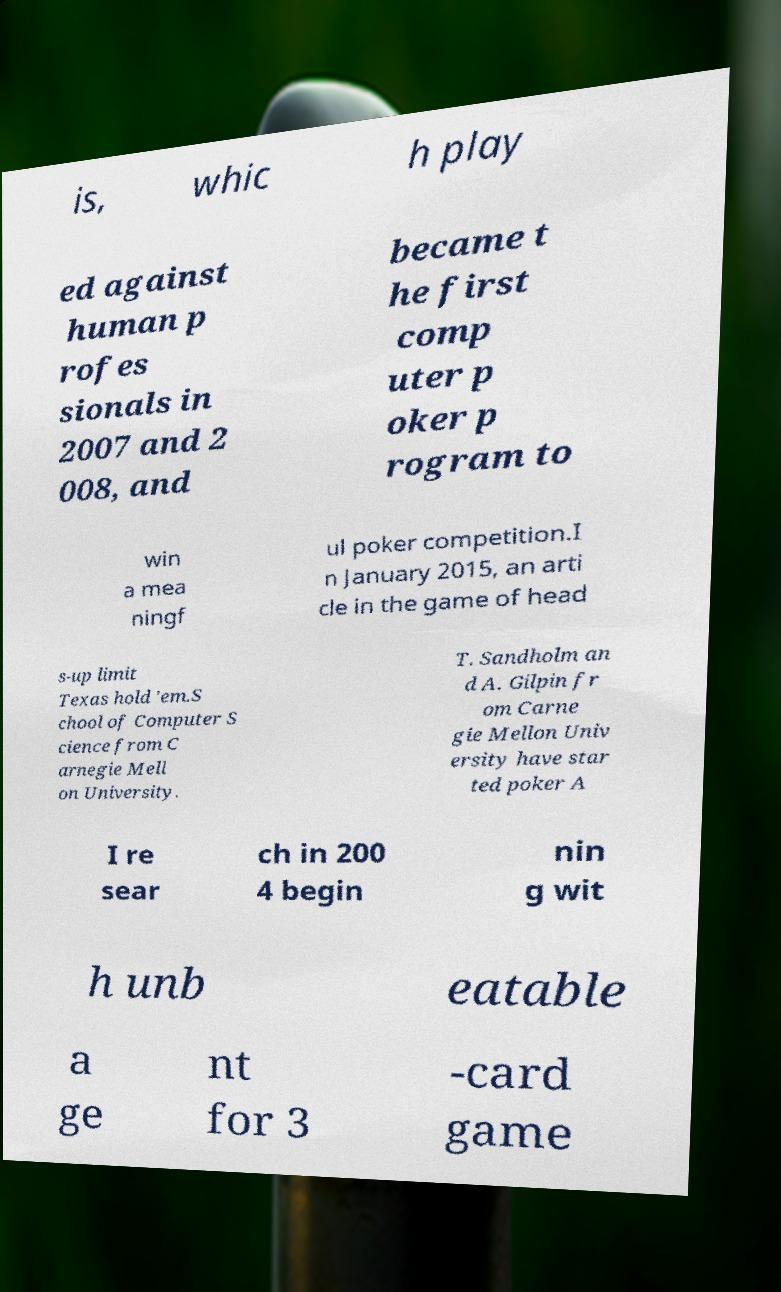What messages or text are displayed in this image? I need them in a readable, typed format. is, whic h play ed against human p rofes sionals in 2007 and 2 008, and became t he first comp uter p oker p rogram to win a mea ningf ul poker competition.I n January 2015, an arti cle in the game of head s-up limit Texas hold 'em.S chool of Computer S cience from C arnegie Mell on University. T. Sandholm an d A. Gilpin fr om Carne gie Mellon Univ ersity have star ted poker A I re sear ch in 200 4 begin nin g wit h unb eatable a ge nt for 3 -card game 